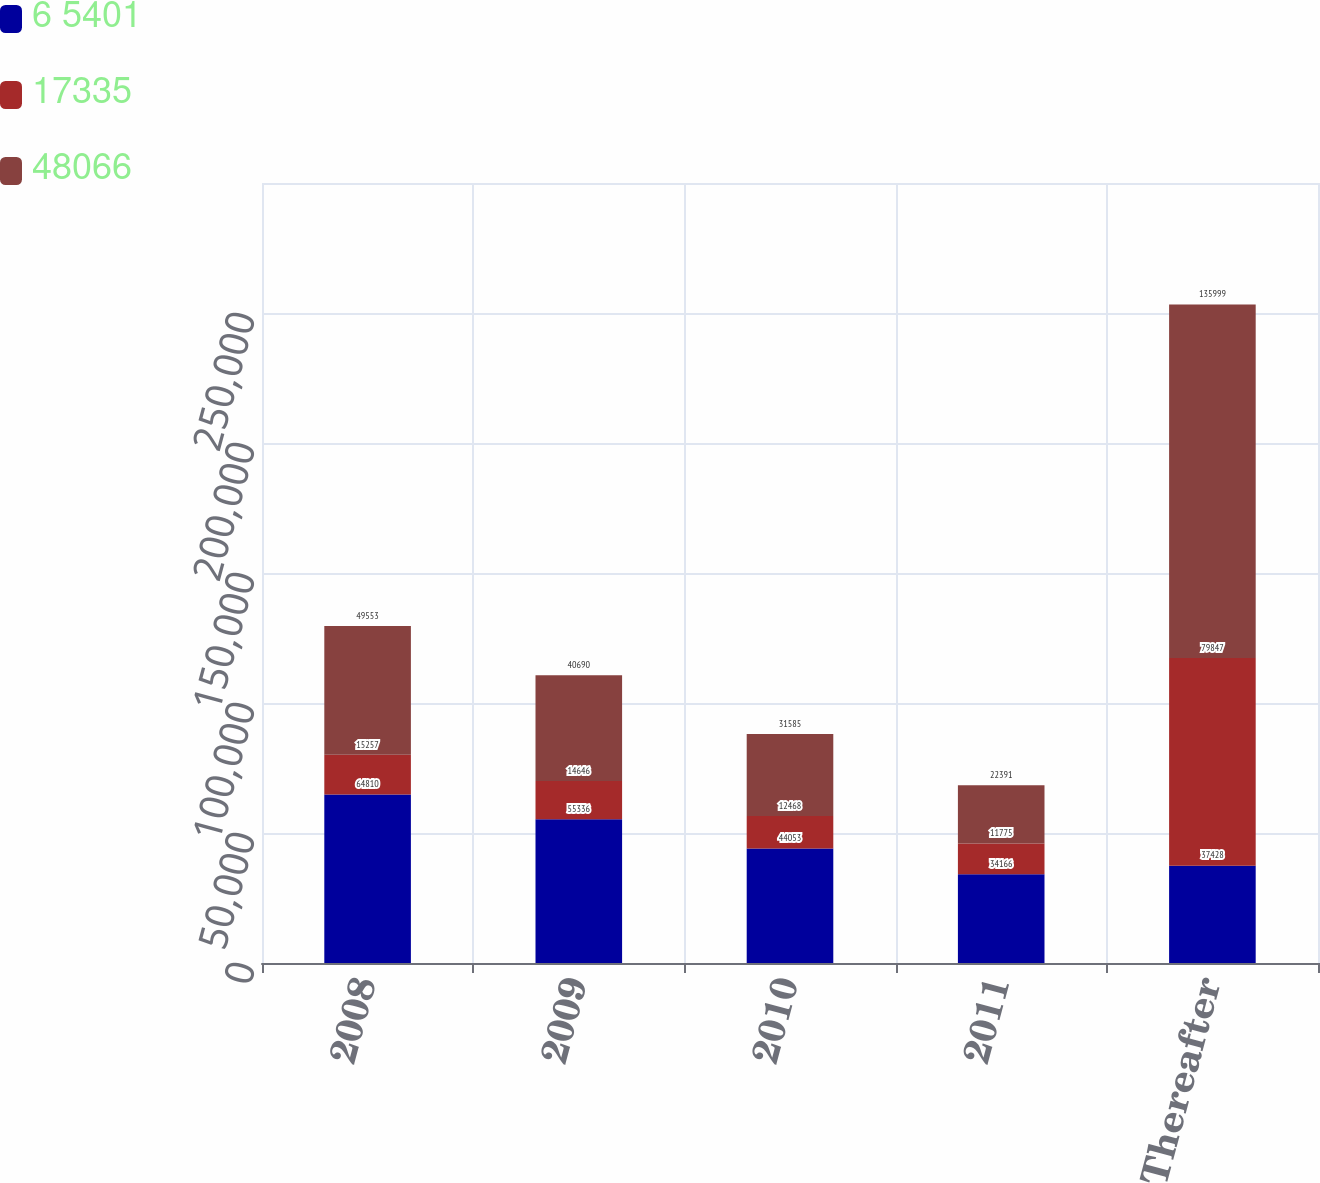Convert chart to OTSL. <chart><loc_0><loc_0><loc_500><loc_500><stacked_bar_chart><ecel><fcel>2008<fcel>2009<fcel>2010<fcel>2011<fcel>Thereafter<nl><fcel>6 5401<fcel>64810<fcel>55336<fcel>44053<fcel>34166<fcel>37428<nl><fcel>17335<fcel>15257<fcel>14646<fcel>12468<fcel>11775<fcel>79847<nl><fcel>48066<fcel>49553<fcel>40690<fcel>31585<fcel>22391<fcel>135999<nl></chart> 